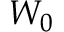Convert formula to latex. <formula><loc_0><loc_0><loc_500><loc_500>W _ { 0 }</formula> 